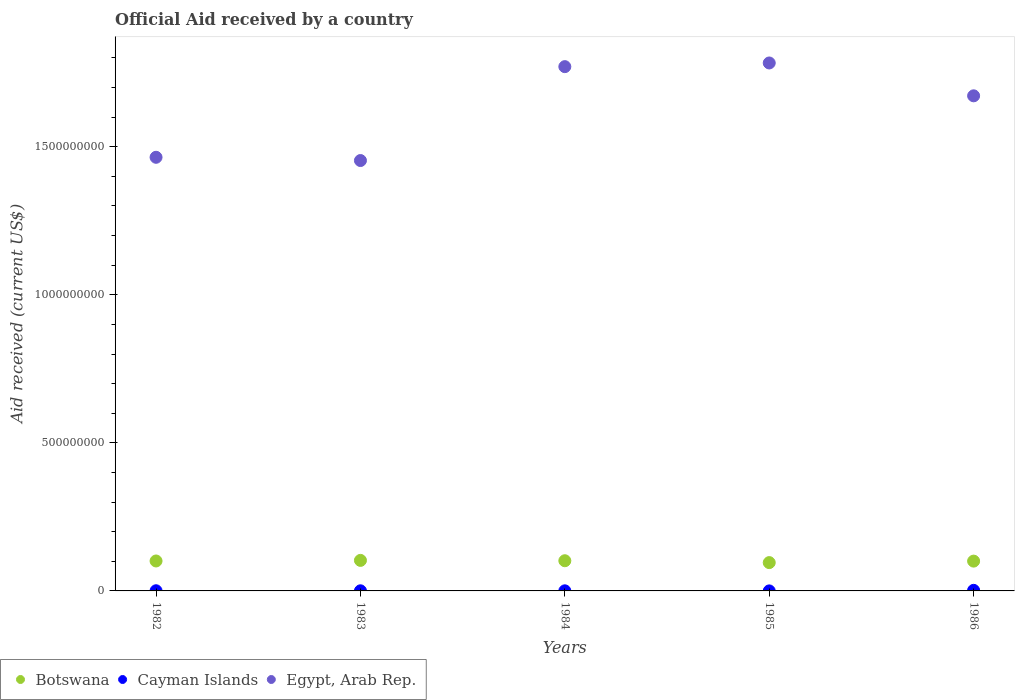What is the net official aid received in Egypt, Arab Rep. in 1984?
Provide a succinct answer. 1.77e+09. Across all years, what is the maximum net official aid received in Botswana?
Offer a very short reply. 1.03e+08. Across all years, what is the minimum net official aid received in Botswana?
Your answer should be compact. 9.56e+07. What is the total net official aid received in Cayman Islands in the graph?
Make the answer very short. 3.34e+06. What is the difference between the net official aid received in Botswana in 1984 and that in 1985?
Provide a succinct answer. 6.31e+06. What is the difference between the net official aid received in Cayman Islands in 1984 and the net official aid received in Egypt, Arab Rep. in 1983?
Provide a succinct answer. -1.45e+09. What is the average net official aid received in Cayman Islands per year?
Your answer should be very brief. 6.68e+05. In the year 1985, what is the difference between the net official aid received in Cayman Islands and net official aid received in Botswana?
Keep it short and to the point. -9.56e+07. In how many years, is the net official aid received in Cayman Islands greater than 600000000 US$?
Your response must be concise. 0. What is the ratio of the net official aid received in Cayman Islands in 1983 to that in 1985?
Offer a terse response. 5.43. Is the net official aid received in Botswana in 1984 less than that in 1985?
Keep it short and to the point. No. What is the difference between the highest and the second highest net official aid received in Egypt, Arab Rep.?
Your answer should be compact. 1.24e+07. What is the difference between the highest and the lowest net official aid received in Egypt, Arab Rep.?
Provide a short and direct response. 3.29e+08. Is the sum of the net official aid received in Egypt, Arab Rep. in 1982 and 1986 greater than the maximum net official aid received in Cayman Islands across all years?
Make the answer very short. Yes. Does the net official aid received in Egypt, Arab Rep. monotonically increase over the years?
Offer a very short reply. No. How many dotlines are there?
Offer a very short reply. 3. How many years are there in the graph?
Offer a very short reply. 5. Are the values on the major ticks of Y-axis written in scientific E-notation?
Offer a terse response. No. Does the graph contain grids?
Your response must be concise. No. Where does the legend appear in the graph?
Your answer should be very brief. Bottom left. How many legend labels are there?
Offer a terse response. 3. What is the title of the graph?
Provide a succinct answer. Official Aid received by a country. Does "Cabo Verde" appear as one of the legend labels in the graph?
Your answer should be very brief. No. What is the label or title of the X-axis?
Keep it short and to the point. Years. What is the label or title of the Y-axis?
Make the answer very short. Aid received (current US$). What is the Aid received (current US$) in Botswana in 1982?
Offer a terse response. 1.01e+08. What is the Aid received (current US$) of Cayman Islands in 1982?
Your answer should be very brief. 5.70e+05. What is the Aid received (current US$) of Egypt, Arab Rep. in 1982?
Give a very brief answer. 1.46e+09. What is the Aid received (current US$) of Botswana in 1983?
Make the answer very short. 1.03e+08. What is the Aid received (current US$) of Cayman Islands in 1983?
Your answer should be compact. 3.80e+05. What is the Aid received (current US$) in Egypt, Arab Rep. in 1983?
Offer a very short reply. 1.45e+09. What is the Aid received (current US$) of Botswana in 1984?
Your answer should be very brief. 1.02e+08. What is the Aid received (current US$) in Cayman Islands in 1984?
Provide a short and direct response. 3.50e+05. What is the Aid received (current US$) in Egypt, Arab Rep. in 1984?
Provide a short and direct response. 1.77e+09. What is the Aid received (current US$) of Botswana in 1985?
Your response must be concise. 9.56e+07. What is the Aid received (current US$) of Egypt, Arab Rep. in 1985?
Ensure brevity in your answer.  1.78e+09. What is the Aid received (current US$) in Botswana in 1986?
Keep it short and to the point. 1.01e+08. What is the Aid received (current US$) of Cayman Islands in 1986?
Ensure brevity in your answer.  1.97e+06. What is the Aid received (current US$) of Egypt, Arab Rep. in 1986?
Offer a terse response. 1.67e+09. Across all years, what is the maximum Aid received (current US$) of Botswana?
Ensure brevity in your answer.  1.03e+08. Across all years, what is the maximum Aid received (current US$) of Cayman Islands?
Give a very brief answer. 1.97e+06. Across all years, what is the maximum Aid received (current US$) of Egypt, Arab Rep.?
Your answer should be compact. 1.78e+09. Across all years, what is the minimum Aid received (current US$) in Botswana?
Provide a short and direct response. 9.56e+07. Across all years, what is the minimum Aid received (current US$) of Egypt, Arab Rep.?
Ensure brevity in your answer.  1.45e+09. What is the total Aid received (current US$) in Botswana in the graph?
Give a very brief answer. 5.02e+08. What is the total Aid received (current US$) in Cayman Islands in the graph?
Provide a succinct answer. 3.34e+06. What is the total Aid received (current US$) in Egypt, Arab Rep. in the graph?
Offer a very short reply. 8.14e+09. What is the difference between the Aid received (current US$) in Botswana in 1982 and that in 1983?
Your response must be concise. -1.98e+06. What is the difference between the Aid received (current US$) in Cayman Islands in 1982 and that in 1983?
Offer a terse response. 1.90e+05. What is the difference between the Aid received (current US$) in Egypt, Arab Rep. in 1982 and that in 1983?
Ensure brevity in your answer.  1.10e+07. What is the difference between the Aid received (current US$) in Botswana in 1982 and that in 1984?
Keep it short and to the point. -7.90e+05. What is the difference between the Aid received (current US$) in Cayman Islands in 1982 and that in 1984?
Offer a very short reply. 2.20e+05. What is the difference between the Aid received (current US$) in Egypt, Arab Rep. in 1982 and that in 1984?
Your response must be concise. -3.06e+08. What is the difference between the Aid received (current US$) of Botswana in 1982 and that in 1985?
Offer a very short reply. 5.52e+06. What is the difference between the Aid received (current US$) in Cayman Islands in 1982 and that in 1985?
Your answer should be compact. 5.00e+05. What is the difference between the Aid received (current US$) of Egypt, Arab Rep. in 1982 and that in 1985?
Provide a succinct answer. -3.18e+08. What is the difference between the Aid received (current US$) in Botswana in 1982 and that in 1986?
Your response must be concise. 4.80e+05. What is the difference between the Aid received (current US$) in Cayman Islands in 1982 and that in 1986?
Your response must be concise. -1.40e+06. What is the difference between the Aid received (current US$) in Egypt, Arab Rep. in 1982 and that in 1986?
Offer a terse response. -2.08e+08. What is the difference between the Aid received (current US$) in Botswana in 1983 and that in 1984?
Keep it short and to the point. 1.19e+06. What is the difference between the Aid received (current US$) of Cayman Islands in 1983 and that in 1984?
Make the answer very short. 3.00e+04. What is the difference between the Aid received (current US$) in Egypt, Arab Rep. in 1983 and that in 1984?
Your response must be concise. -3.17e+08. What is the difference between the Aid received (current US$) of Botswana in 1983 and that in 1985?
Ensure brevity in your answer.  7.50e+06. What is the difference between the Aid received (current US$) in Cayman Islands in 1983 and that in 1985?
Give a very brief answer. 3.10e+05. What is the difference between the Aid received (current US$) in Egypt, Arab Rep. in 1983 and that in 1985?
Your answer should be compact. -3.29e+08. What is the difference between the Aid received (current US$) in Botswana in 1983 and that in 1986?
Offer a very short reply. 2.46e+06. What is the difference between the Aid received (current US$) in Cayman Islands in 1983 and that in 1986?
Ensure brevity in your answer.  -1.59e+06. What is the difference between the Aid received (current US$) of Egypt, Arab Rep. in 1983 and that in 1986?
Provide a succinct answer. -2.19e+08. What is the difference between the Aid received (current US$) in Botswana in 1984 and that in 1985?
Offer a very short reply. 6.31e+06. What is the difference between the Aid received (current US$) in Cayman Islands in 1984 and that in 1985?
Your answer should be compact. 2.80e+05. What is the difference between the Aid received (current US$) in Egypt, Arab Rep. in 1984 and that in 1985?
Your answer should be very brief. -1.24e+07. What is the difference between the Aid received (current US$) in Botswana in 1984 and that in 1986?
Keep it short and to the point. 1.27e+06. What is the difference between the Aid received (current US$) of Cayman Islands in 1984 and that in 1986?
Keep it short and to the point. -1.62e+06. What is the difference between the Aid received (current US$) in Egypt, Arab Rep. in 1984 and that in 1986?
Provide a succinct answer. 9.85e+07. What is the difference between the Aid received (current US$) of Botswana in 1985 and that in 1986?
Offer a very short reply. -5.04e+06. What is the difference between the Aid received (current US$) in Cayman Islands in 1985 and that in 1986?
Offer a very short reply. -1.90e+06. What is the difference between the Aid received (current US$) in Egypt, Arab Rep. in 1985 and that in 1986?
Your response must be concise. 1.11e+08. What is the difference between the Aid received (current US$) in Botswana in 1982 and the Aid received (current US$) in Cayman Islands in 1983?
Your response must be concise. 1.01e+08. What is the difference between the Aid received (current US$) of Botswana in 1982 and the Aid received (current US$) of Egypt, Arab Rep. in 1983?
Keep it short and to the point. -1.35e+09. What is the difference between the Aid received (current US$) of Cayman Islands in 1982 and the Aid received (current US$) of Egypt, Arab Rep. in 1983?
Your response must be concise. -1.45e+09. What is the difference between the Aid received (current US$) of Botswana in 1982 and the Aid received (current US$) of Cayman Islands in 1984?
Keep it short and to the point. 1.01e+08. What is the difference between the Aid received (current US$) in Botswana in 1982 and the Aid received (current US$) in Egypt, Arab Rep. in 1984?
Offer a very short reply. -1.67e+09. What is the difference between the Aid received (current US$) in Cayman Islands in 1982 and the Aid received (current US$) in Egypt, Arab Rep. in 1984?
Your answer should be compact. -1.77e+09. What is the difference between the Aid received (current US$) in Botswana in 1982 and the Aid received (current US$) in Cayman Islands in 1985?
Give a very brief answer. 1.01e+08. What is the difference between the Aid received (current US$) of Botswana in 1982 and the Aid received (current US$) of Egypt, Arab Rep. in 1985?
Offer a very short reply. -1.68e+09. What is the difference between the Aid received (current US$) of Cayman Islands in 1982 and the Aid received (current US$) of Egypt, Arab Rep. in 1985?
Make the answer very short. -1.78e+09. What is the difference between the Aid received (current US$) of Botswana in 1982 and the Aid received (current US$) of Cayman Islands in 1986?
Your response must be concise. 9.92e+07. What is the difference between the Aid received (current US$) of Botswana in 1982 and the Aid received (current US$) of Egypt, Arab Rep. in 1986?
Your answer should be compact. -1.57e+09. What is the difference between the Aid received (current US$) of Cayman Islands in 1982 and the Aid received (current US$) of Egypt, Arab Rep. in 1986?
Your response must be concise. -1.67e+09. What is the difference between the Aid received (current US$) of Botswana in 1983 and the Aid received (current US$) of Cayman Islands in 1984?
Ensure brevity in your answer.  1.03e+08. What is the difference between the Aid received (current US$) in Botswana in 1983 and the Aid received (current US$) in Egypt, Arab Rep. in 1984?
Provide a short and direct response. -1.67e+09. What is the difference between the Aid received (current US$) of Cayman Islands in 1983 and the Aid received (current US$) of Egypt, Arab Rep. in 1984?
Give a very brief answer. -1.77e+09. What is the difference between the Aid received (current US$) of Botswana in 1983 and the Aid received (current US$) of Cayman Islands in 1985?
Offer a very short reply. 1.03e+08. What is the difference between the Aid received (current US$) of Botswana in 1983 and the Aid received (current US$) of Egypt, Arab Rep. in 1985?
Keep it short and to the point. -1.68e+09. What is the difference between the Aid received (current US$) of Cayman Islands in 1983 and the Aid received (current US$) of Egypt, Arab Rep. in 1985?
Your answer should be very brief. -1.78e+09. What is the difference between the Aid received (current US$) of Botswana in 1983 and the Aid received (current US$) of Cayman Islands in 1986?
Offer a very short reply. 1.01e+08. What is the difference between the Aid received (current US$) in Botswana in 1983 and the Aid received (current US$) in Egypt, Arab Rep. in 1986?
Your response must be concise. -1.57e+09. What is the difference between the Aid received (current US$) in Cayman Islands in 1983 and the Aid received (current US$) in Egypt, Arab Rep. in 1986?
Ensure brevity in your answer.  -1.67e+09. What is the difference between the Aid received (current US$) of Botswana in 1984 and the Aid received (current US$) of Cayman Islands in 1985?
Provide a short and direct response. 1.02e+08. What is the difference between the Aid received (current US$) of Botswana in 1984 and the Aid received (current US$) of Egypt, Arab Rep. in 1985?
Your answer should be compact. -1.68e+09. What is the difference between the Aid received (current US$) of Cayman Islands in 1984 and the Aid received (current US$) of Egypt, Arab Rep. in 1985?
Keep it short and to the point. -1.78e+09. What is the difference between the Aid received (current US$) in Botswana in 1984 and the Aid received (current US$) in Cayman Islands in 1986?
Your response must be concise. 1.00e+08. What is the difference between the Aid received (current US$) of Botswana in 1984 and the Aid received (current US$) of Egypt, Arab Rep. in 1986?
Provide a short and direct response. -1.57e+09. What is the difference between the Aid received (current US$) of Cayman Islands in 1984 and the Aid received (current US$) of Egypt, Arab Rep. in 1986?
Give a very brief answer. -1.67e+09. What is the difference between the Aid received (current US$) of Botswana in 1985 and the Aid received (current US$) of Cayman Islands in 1986?
Your answer should be very brief. 9.36e+07. What is the difference between the Aid received (current US$) of Botswana in 1985 and the Aid received (current US$) of Egypt, Arab Rep. in 1986?
Ensure brevity in your answer.  -1.58e+09. What is the difference between the Aid received (current US$) in Cayman Islands in 1985 and the Aid received (current US$) in Egypt, Arab Rep. in 1986?
Offer a terse response. -1.67e+09. What is the average Aid received (current US$) of Botswana per year?
Keep it short and to the point. 1.00e+08. What is the average Aid received (current US$) in Cayman Islands per year?
Your answer should be compact. 6.68e+05. What is the average Aid received (current US$) of Egypt, Arab Rep. per year?
Ensure brevity in your answer.  1.63e+09. In the year 1982, what is the difference between the Aid received (current US$) of Botswana and Aid received (current US$) of Cayman Islands?
Your response must be concise. 1.01e+08. In the year 1982, what is the difference between the Aid received (current US$) of Botswana and Aid received (current US$) of Egypt, Arab Rep.?
Your response must be concise. -1.36e+09. In the year 1982, what is the difference between the Aid received (current US$) in Cayman Islands and Aid received (current US$) in Egypt, Arab Rep.?
Keep it short and to the point. -1.46e+09. In the year 1983, what is the difference between the Aid received (current US$) in Botswana and Aid received (current US$) in Cayman Islands?
Ensure brevity in your answer.  1.03e+08. In the year 1983, what is the difference between the Aid received (current US$) of Botswana and Aid received (current US$) of Egypt, Arab Rep.?
Keep it short and to the point. -1.35e+09. In the year 1983, what is the difference between the Aid received (current US$) of Cayman Islands and Aid received (current US$) of Egypt, Arab Rep.?
Your response must be concise. -1.45e+09. In the year 1984, what is the difference between the Aid received (current US$) of Botswana and Aid received (current US$) of Cayman Islands?
Your answer should be compact. 1.02e+08. In the year 1984, what is the difference between the Aid received (current US$) of Botswana and Aid received (current US$) of Egypt, Arab Rep.?
Offer a terse response. -1.67e+09. In the year 1984, what is the difference between the Aid received (current US$) of Cayman Islands and Aid received (current US$) of Egypt, Arab Rep.?
Offer a very short reply. -1.77e+09. In the year 1985, what is the difference between the Aid received (current US$) of Botswana and Aid received (current US$) of Cayman Islands?
Provide a succinct answer. 9.56e+07. In the year 1985, what is the difference between the Aid received (current US$) in Botswana and Aid received (current US$) in Egypt, Arab Rep.?
Offer a terse response. -1.69e+09. In the year 1985, what is the difference between the Aid received (current US$) in Cayman Islands and Aid received (current US$) in Egypt, Arab Rep.?
Your response must be concise. -1.78e+09. In the year 1986, what is the difference between the Aid received (current US$) in Botswana and Aid received (current US$) in Cayman Islands?
Make the answer very short. 9.87e+07. In the year 1986, what is the difference between the Aid received (current US$) of Botswana and Aid received (current US$) of Egypt, Arab Rep.?
Offer a very short reply. -1.57e+09. In the year 1986, what is the difference between the Aid received (current US$) in Cayman Islands and Aid received (current US$) in Egypt, Arab Rep.?
Your answer should be very brief. -1.67e+09. What is the ratio of the Aid received (current US$) in Botswana in 1982 to that in 1983?
Provide a succinct answer. 0.98. What is the ratio of the Aid received (current US$) of Cayman Islands in 1982 to that in 1983?
Your response must be concise. 1.5. What is the ratio of the Aid received (current US$) of Egypt, Arab Rep. in 1982 to that in 1983?
Your answer should be compact. 1.01. What is the ratio of the Aid received (current US$) of Cayman Islands in 1982 to that in 1984?
Your response must be concise. 1.63. What is the ratio of the Aid received (current US$) in Egypt, Arab Rep. in 1982 to that in 1984?
Offer a very short reply. 0.83. What is the ratio of the Aid received (current US$) of Botswana in 1982 to that in 1985?
Offer a very short reply. 1.06. What is the ratio of the Aid received (current US$) of Cayman Islands in 1982 to that in 1985?
Make the answer very short. 8.14. What is the ratio of the Aid received (current US$) in Egypt, Arab Rep. in 1982 to that in 1985?
Ensure brevity in your answer.  0.82. What is the ratio of the Aid received (current US$) in Botswana in 1982 to that in 1986?
Your answer should be very brief. 1. What is the ratio of the Aid received (current US$) of Cayman Islands in 1982 to that in 1986?
Give a very brief answer. 0.29. What is the ratio of the Aid received (current US$) of Egypt, Arab Rep. in 1982 to that in 1986?
Offer a terse response. 0.88. What is the ratio of the Aid received (current US$) of Botswana in 1983 to that in 1984?
Provide a short and direct response. 1.01. What is the ratio of the Aid received (current US$) in Cayman Islands in 1983 to that in 1984?
Your answer should be very brief. 1.09. What is the ratio of the Aid received (current US$) of Egypt, Arab Rep. in 1983 to that in 1984?
Provide a short and direct response. 0.82. What is the ratio of the Aid received (current US$) in Botswana in 1983 to that in 1985?
Give a very brief answer. 1.08. What is the ratio of the Aid received (current US$) of Cayman Islands in 1983 to that in 1985?
Offer a terse response. 5.43. What is the ratio of the Aid received (current US$) of Egypt, Arab Rep. in 1983 to that in 1985?
Your response must be concise. 0.82. What is the ratio of the Aid received (current US$) of Botswana in 1983 to that in 1986?
Give a very brief answer. 1.02. What is the ratio of the Aid received (current US$) of Cayman Islands in 1983 to that in 1986?
Provide a succinct answer. 0.19. What is the ratio of the Aid received (current US$) of Egypt, Arab Rep. in 1983 to that in 1986?
Provide a short and direct response. 0.87. What is the ratio of the Aid received (current US$) in Botswana in 1984 to that in 1985?
Keep it short and to the point. 1.07. What is the ratio of the Aid received (current US$) in Cayman Islands in 1984 to that in 1985?
Provide a short and direct response. 5. What is the ratio of the Aid received (current US$) of Botswana in 1984 to that in 1986?
Offer a very short reply. 1.01. What is the ratio of the Aid received (current US$) in Cayman Islands in 1984 to that in 1986?
Provide a short and direct response. 0.18. What is the ratio of the Aid received (current US$) in Egypt, Arab Rep. in 1984 to that in 1986?
Your response must be concise. 1.06. What is the ratio of the Aid received (current US$) of Botswana in 1985 to that in 1986?
Make the answer very short. 0.95. What is the ratio of the Aid received (current US$) in Cayman Islands in 1985 to that in 1986?
Give a very brief answer. 0.04. What is the ratio of the Aid received (current US$) in Egypt, Arab Rep. in 1985 to that in 1986?
Offer a terse response. 1.07. What is the difference between the highest and the second highest Aid received (current US$) of Botswana?
Your response must be concise. 1.19e+06. What is the difference between the highest and the second highest Aid received (current US$) in Cayman Islands?
Make the answer very short. 1.40e+06. What is the difference between the highest and the second highest Aid received (current US$) of Egypt, Arab Rep.?
Provide a short and direct response. 1.24e+07. What is the difference between the highest and the lowest Aid received (current US$) in Botswana?
Your response must be concise. 7.50e+06. What is the difference between the highest and the lowest Aid received (current US$) in Cayman Islands?
Provide a succinct answer. 1.90e+06. What is the difference between the highest and the lowest Aid received (current US$) of Egypt, Arab Rep.?
Provide a short and direct response. 3.29e+08. 